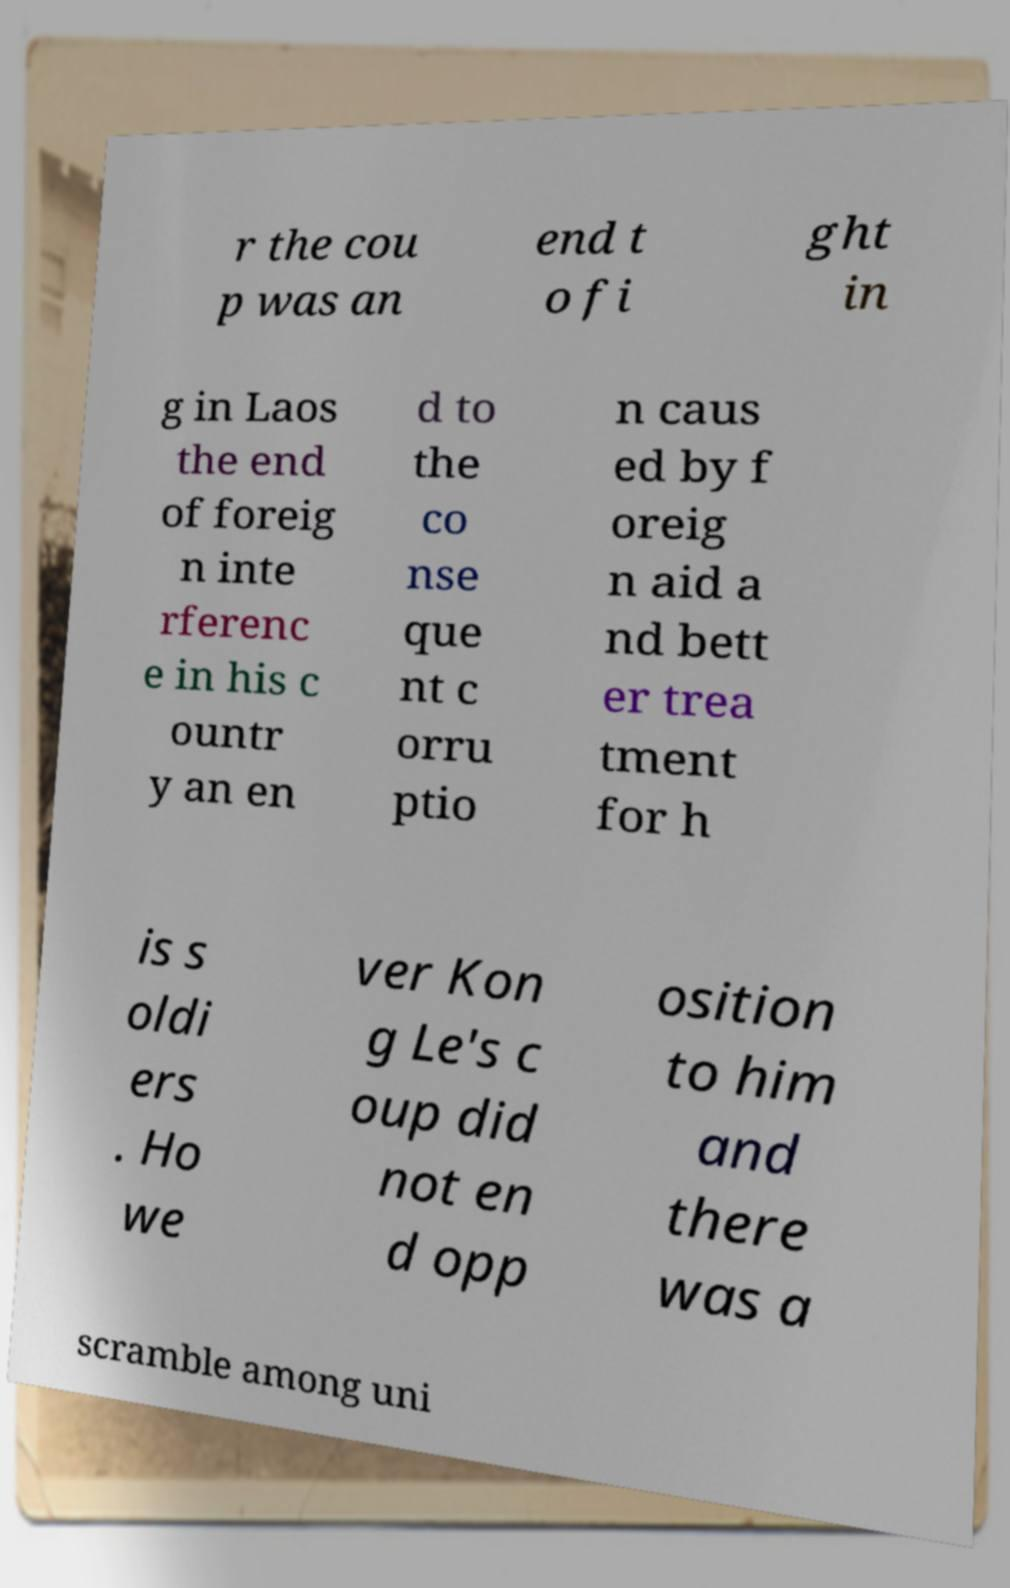For documentation purposes, I need the text within this image transcribed. Could you provide that? r the cou p was an end t o fi ght in g in Laos the end of foreig n inte rferenc e in his c ountr y an en d to the co nse que nt c orru ptio n caus ed by f oreig n aid a nd bett er trea tment for h is s oldi ers . Ho we ver Kon g Le's c oup did not en d opp osition to him and there was a scramble among uni 